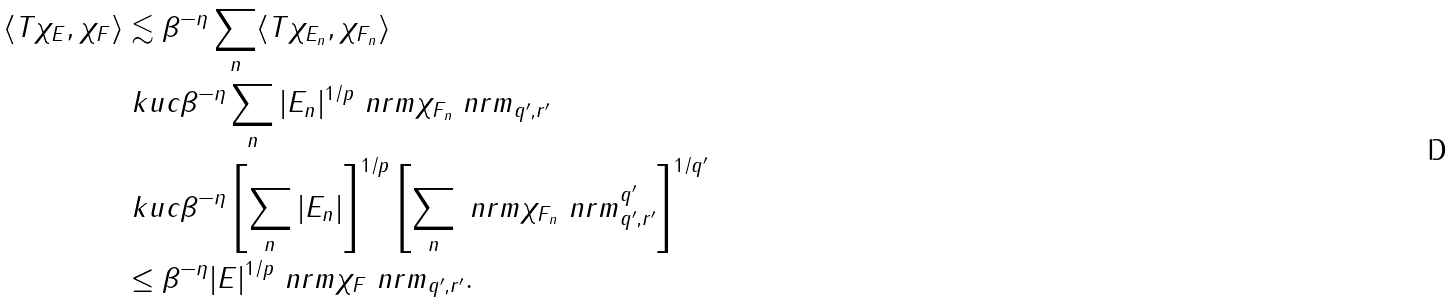Convert formula to latex. <formula><loc_0><loc_0><loc_500><loc_500>\langle T \chi _ { E } , \chi _ { F } \rangle & \lesssim \beta ^ { - \eta } \sum _ { n } \langle T \chi _ { E _ { n } } , \chi _ { F _ { n } } \rangle \\ & \ k u c \beta ^ { - \eta } \sum _ { n } | E _ { n } | ^ { 1 / p } \ n r m \chi _ { F _ { n } } \ n r m _ { q ^ { \prime } , r ^ { \prime } } \\ & \ k u c \beta ^ { - \eta } \left [ \sum _ { n } | E _ { n } | \right ] ^ { 1 / p } \left [ \sum _ { n } \ n r m \chi _ { F _ { n } } \ n r m _ { q ^ { \prime } , r ^ { \prime } } ^ { q ^ { \prime } } \right ] ^ { 1 / q ^ { \prime } } \\ & \leq \beta ^ { - \eta } | E | ^ { 1 / p } \ n r m \chi _ { F } \ n r m _ { q ^ { \prime } , r ^ { \prime } } .</formula> 